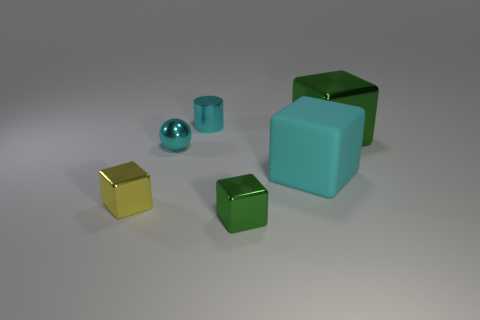Subtract all red cylinders. How many green cubes are left? 2 Subtract all big cyan blocks. How many blocks are left? 3 Subtract all cyan blocks. How many blocks are left? 3 Add 4 small cyan metal spheres. How many objects exist? 10 Subtract all purple cubes. Subtract all purple spheres. How many cubes are left? 4 Add 5 rubber blocks. How many rubber blocks exist? 6 Subtract 1 cyan balls. How many objects are left? 5 Subtract all cylinders. How many objects are left? 5 Subtract all small red rubber cubes. Subtract all small metal cylinders. How many objects are left? 5 Add 3 green objects. How many green objects are left? 5 